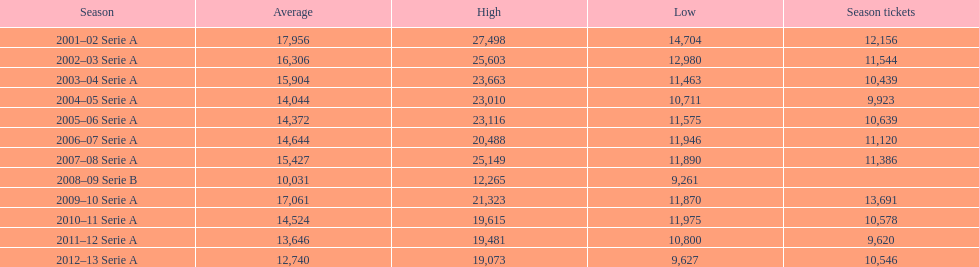In 2007, how many season tickets were there? 11,386. 